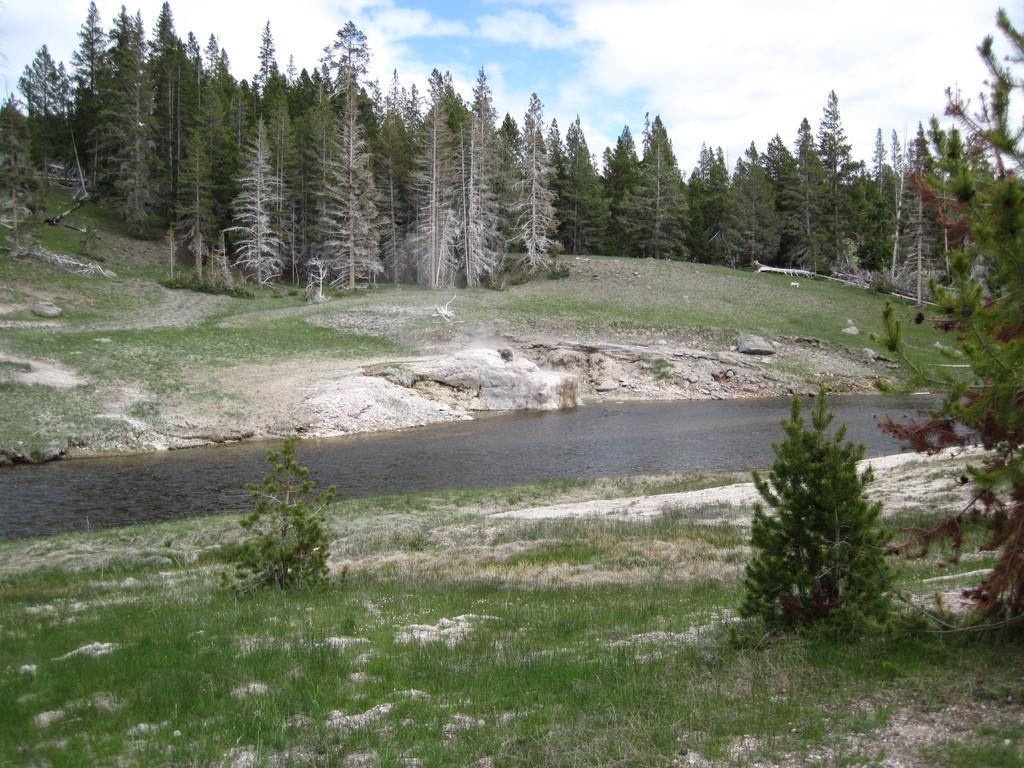Could you give a brief overview of what you see in this image? In the foreground of this image, there is the grassland and few trees on it. In the middle, there is a river flowing. In the background, there are trees, sky and the cloud. 